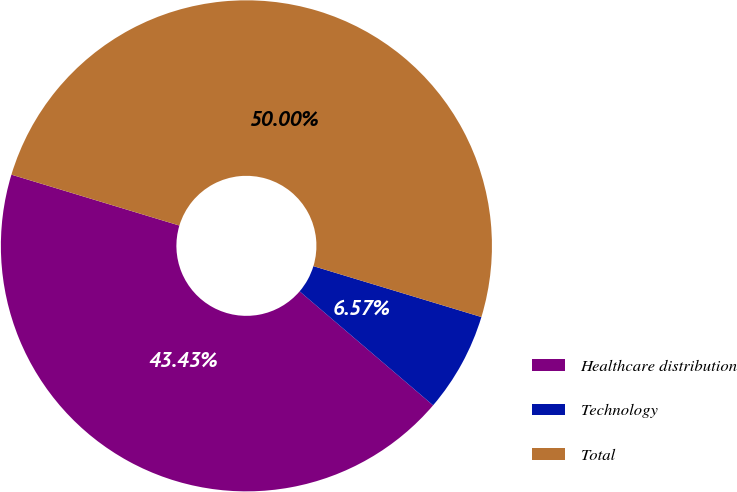Convert chart to OTSL. <chart><loc_0><loc_0><loc_500><loc_500><pie_chart><fcel>Healthcare distribution<fcel>Technology<fcel>Total<nl><fcel>43.43%<fcel>6.57%<fcel>50.0%<nl></chart> 